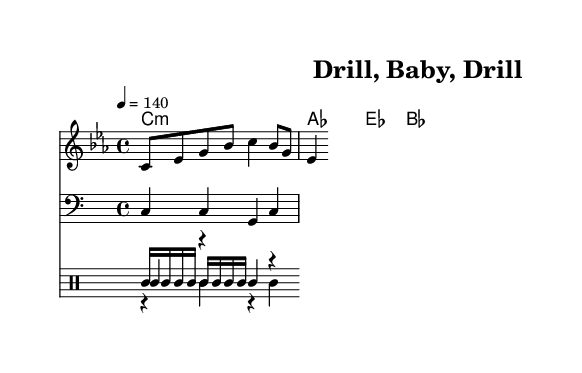What is the key signature of this music? The key signature is C minor, which has three flats. Looking at the clef and the key signature indicated at the beginning of the staff, we can see the marks representing three flat notes.
Answer: C minor What is the time signature of this music? The time signature is 4/4, which indicates that there are four beats in a measure and a quarter note receives one beat. The time signature is displayed at the beginning of the staff before the notes begin.
Answer: 4/4 What is the tempo marking in this piece? The tempo marking is 140 BPM, indicating that the tempo is set at beats per minute. This can be found in the tempo instruction next to the global settings at the start of the score.
Answer: 140 How many measures are in the melody section? There are two measures in the melody section, clearly defined by the grouping of notes and the placement of bar lines. Counting the segments of notes between the bar lines gives us the total number of measures.
Answer: 2 What instrument is indicated for the bass line? The bass line is indicated for a bass instrument as seen in the part labeled "Staff" with "clef bass". This means the music is intended for a bass presentation.
Answer: Bass What type of mood does the song’s lyrics suggest? The song’s lyrics suggest a confident and industrious mood with the phrase "Drill, baby, drill, that's how we pay the bills," implying a strong dedication to the industry being celebrated, which is a hallmark of trap music and its themes.
Answer: Confident What genre does this song represent? This song represents the trap music genre, a sub-genre of hip hop that often celebrates themes tied to industry, lifestyle, and ambitions like manufacturing and oil. This can be inferred from the rhythmic structure and the lyrical content focused on these industries.
Answer: Trap music 